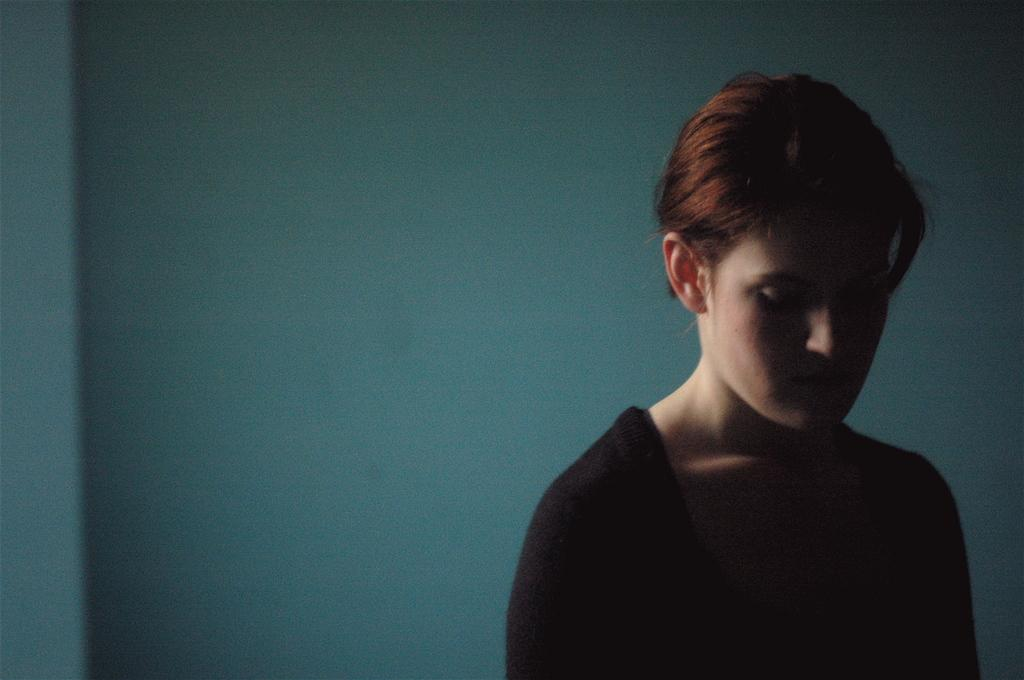Who is present in the image? There is a woman in the image. What can be seen in the background of the image? There is a wall in the background of the image. What type of silk is the woman wearing in the image? There is no mention of silk or any specific clothing in the image, so it cannot be determined what the woman is wearing. 